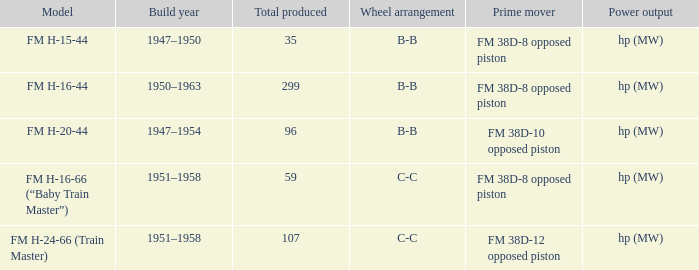Which is the smallest Total produced with a model of FM H-15-44? 35.0. 